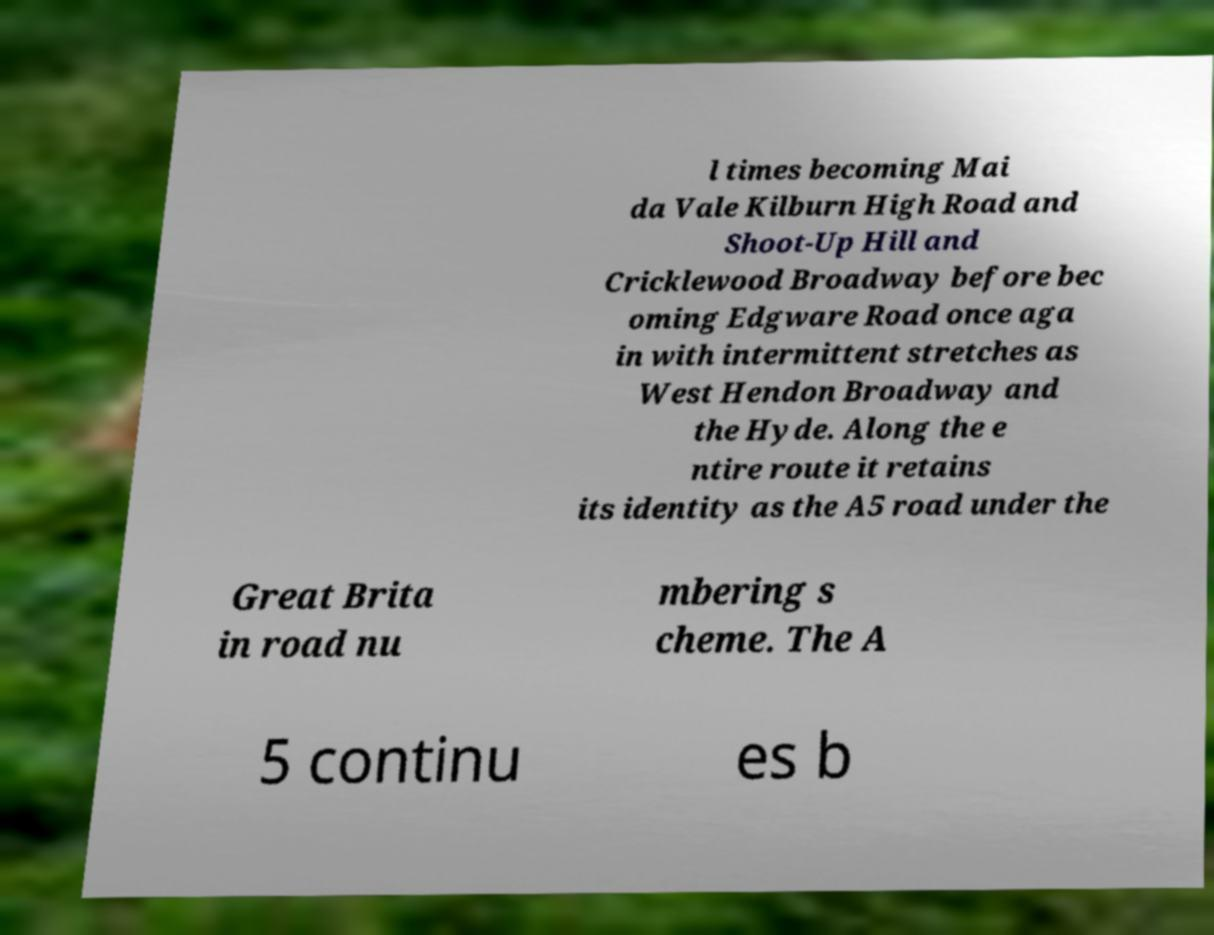Could you assist in decoding the text presented in this image and type it out clearly? l times becoming Mai da Vale Kilburn High Road and Shoot-Up Hill and Cricklewood Broadway before bec oming Edgware Road once aga in with intermittent stretches as West Hendon Broadway and the Hyde. Along the e ntire route it retains its identity as the A5 road under the Great Brita in road nu mbering s cheme. The A 5 continu es b 